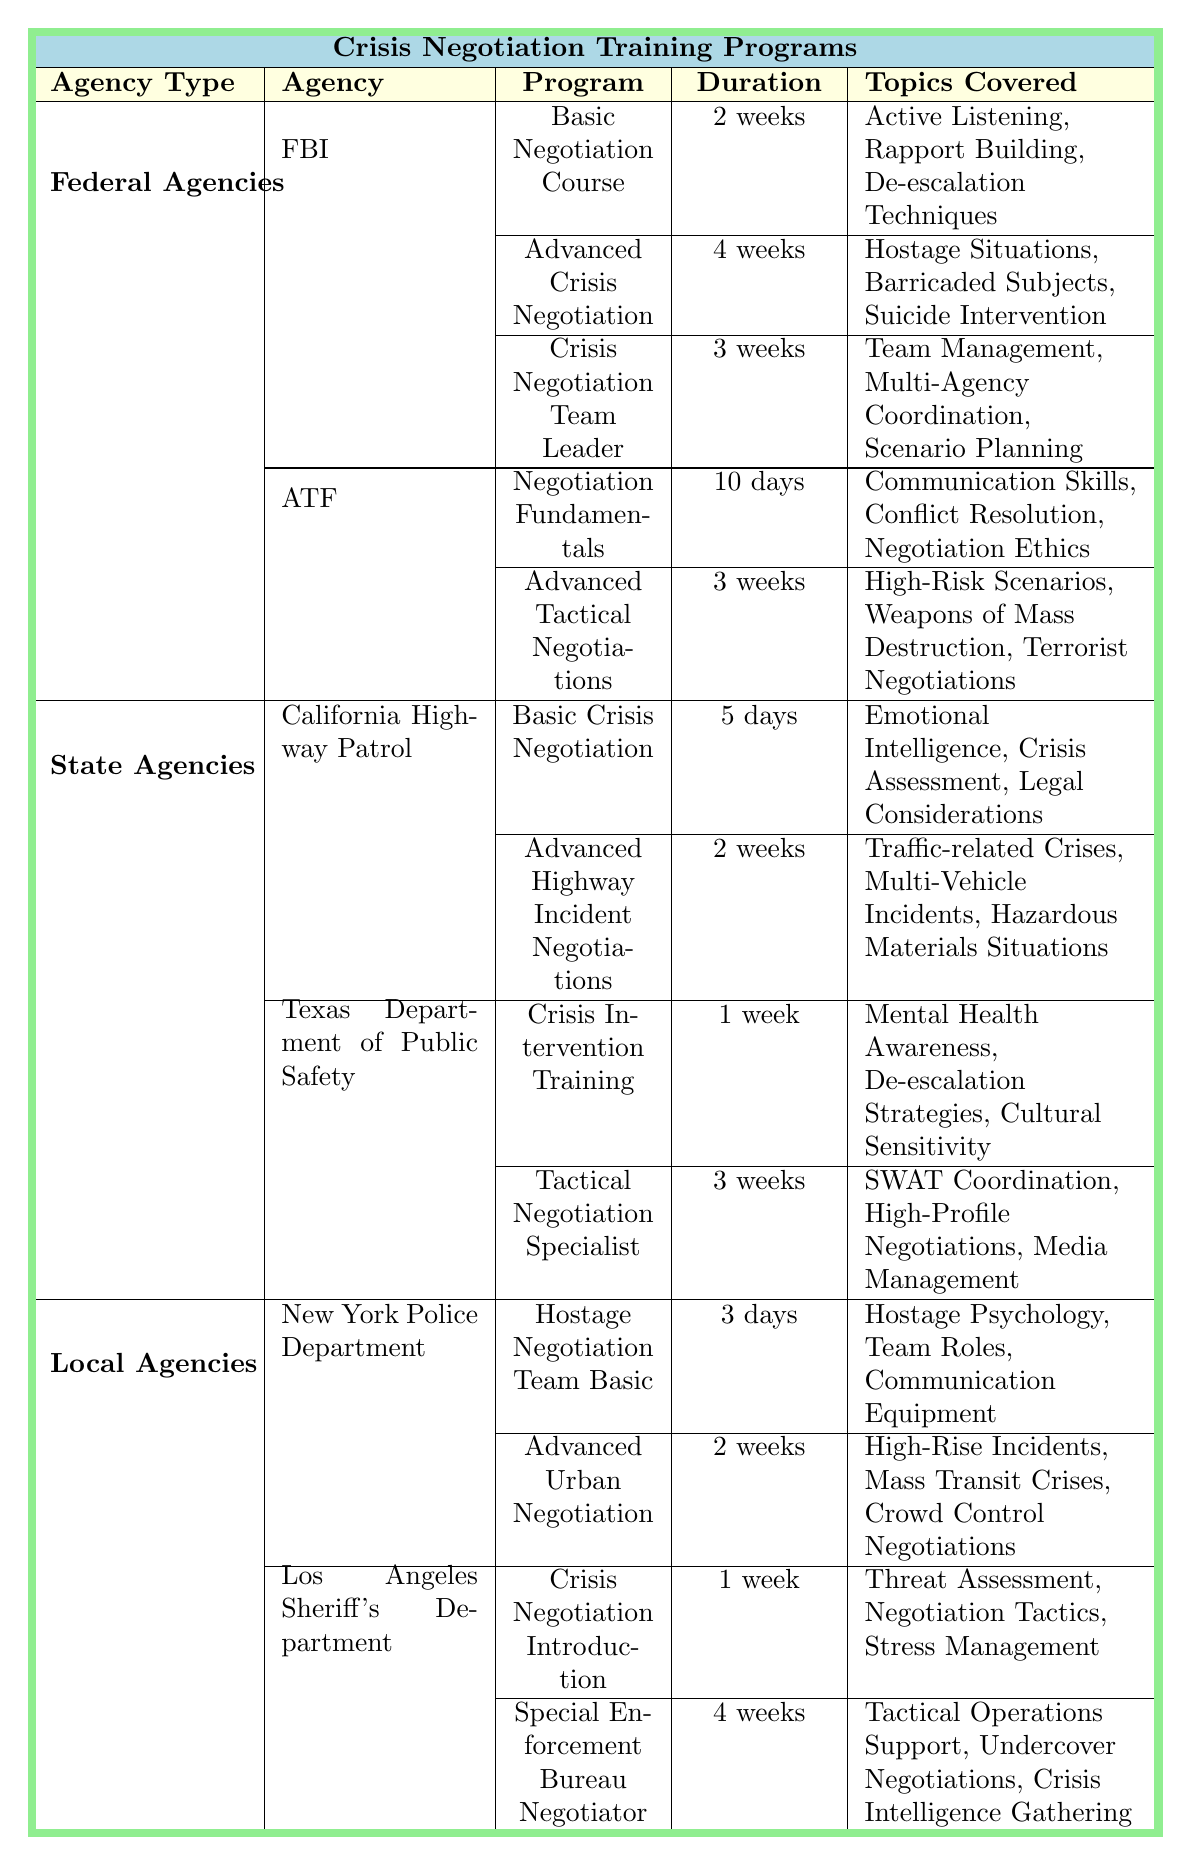What is the duration of the Advanced Crisis Negotiation course offered by the FBI? The table lists the duration of the Advanced Crisis Negotiation course under the FBI section. It shows that this course lasts for 4 weeks.
Answer: 4 weeks Which agency offers a Crisis Negotiation Introduction program? In the Local Agencies section of the table, it shows that the Los Angeles Sheriff's Department offers a Crisis Negotiation Introduction program.
Answer: Los Angeles Sheriff's Department How many days does the Basic Crisis Negotiation course from the California Highway Patrol last? The table state that the Basic Crisis Negotiation course from the California Highway Patrol has a duration of 5 days.
Answer: 5 days Is the certification level for the Tactical Negotiation Specialist program advanced? The table lists that the Tactical Negotiation Specialist program has a certification level marked as advanced. Therefore, the statement is true.
Answer: Yes How many different programs does the ATF offer for crisis negotiation and what are their certification levels? The ATF offers two programs: Negotiation Fundamentals with an entry-level certification and Advanced Tactical Negotiations with an advanced-level certification. Thus, the ATF offers 2 programs with levels entry and advanced.
Answer: 2 programs: Entry and Advanced Which agency has the longest duration for an entry-level crisis negotiation program? From the table, the ATF offers the Negotiation Fundamentals program for 10 days, which is longer than any entry-level programs from other agencies listed, such as the 5 days from California Highway Patrol and 3 days from New York Police Department.
Answer: ATF What is the average duration of advanced-level crisis negotiation programs across all agencies? The advanced-level programs listed are Advanced Crisis Negotiation (FBI, 4 weeks), Advanced Tactical Negotiations (ATF, 3 weeks), Tactical Negotiation Specialist (Texas Department of Public Safety, 3 weeks), Special Enforcement Bureau Negotiator (Los Angeles Sheriff's Department, 4 weeks). The total is 4 + 3 + 3 + 4 = 14 weeks, divided by 4 gives an average of 3.5 weeks.
Answer: 3.5 weeks Which program involves crisis intelligence gathering, and what is the corresponding agency? The table indicates that the Special Enforcement Bureau Negotiator program involves crisis intelligence gathering, which is offered by the Los Angeles Sheriff's Department.
Answer: Special Enforcement Bureau Negotiator; Los Angeles Sheriff's Department Are there any programs that cover cultural sensitivity in the training? Yes, the Crisis Intervention Training program from the Texas Department of Public Safety includes cultural sensitivity in its topics covered. Therefore, the statement is true.
Answer: Yes Which agency has a program with the shortest duration and what is that duration? According to the table, the Hostage Negotiation Team Basic program from the New York Police Department lasts for 3 days, which is the shortest duration compared to others listed.
Answer: 3 days What are the total number of crisis negotiation programs offered across all three agency types? The total number of programs listed is: 3 (FBI) + 2 (ATF) + 2 (California Highway Patrol) + 2 (Texas Department of Public Safety) + 2 (New York Police Department) + 2 (Los Angeles Sheriff's Department) = 13 programs.
Answer: 13 programs 